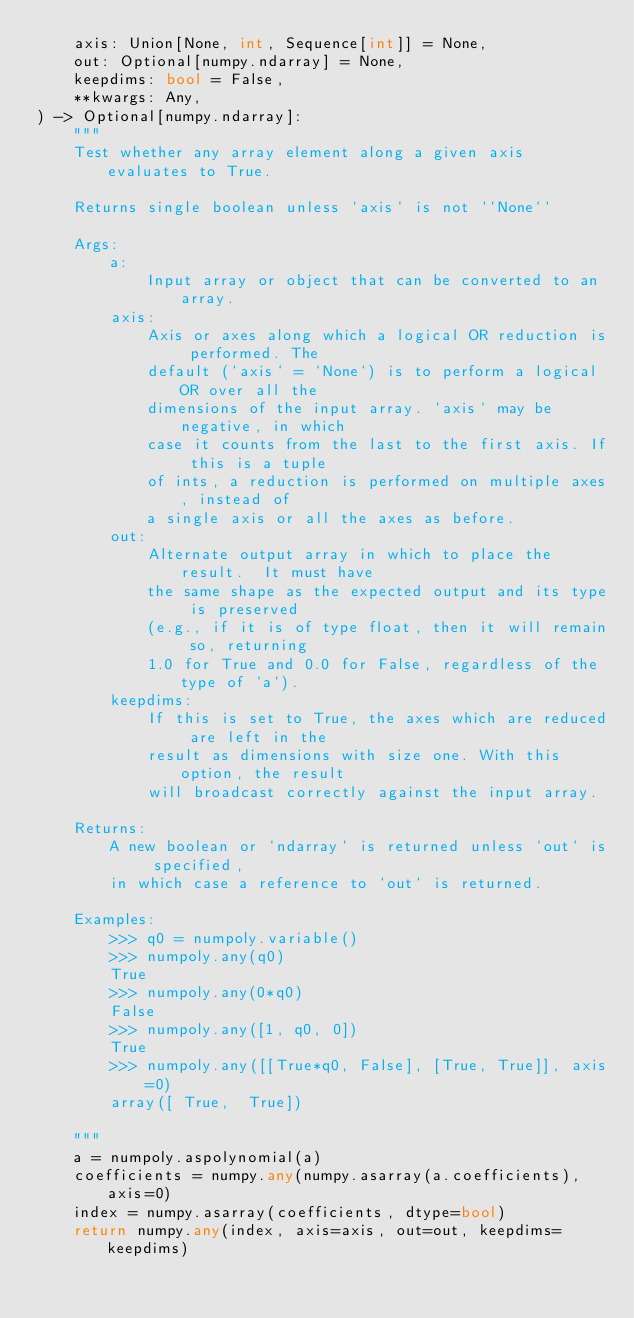<code> <loc_0><loc_0><loc_500><loc_500><_Python_>    axis: Union[None, int, Sequence[int]] = None,
    out: Optional[numpy.ndarray] = None,
    keepdims: bool = False,
    **kwargs: Any,
) -> Optional[numpy.ndarray]:
    """
    Test whether any array element along a given axis evaluates to True.

    Returns single boolean unless `axis` is not ``None``

    Args:
        a:
            Input array or object that can be converted to an array.
        axis:
            Axis or axes along which a logical OR reduction is performed. The
            default (`axis` = `None`) is to perform a logical OR over all the
            dimensions of the input array. `axis` may be negative, in which
            case it counts from the last to the first axis. If this is a tuple
            of ints, a reduction is performed on multiple axes, instead of
            a single axis or all the axes as before.
        out:
            Alternate output array in which to place the result.  It must have
            the same shape as the expected output and its type is preserved
            (e.g., if it is of type float, then it will remain so, returning
            1.0 for True and 0.0 for False, regardless of the type of `a`).
        keepdims:
            If this is set to True, the axes which are reduced are left in the
            result as dimensions with size one. With this option, the result
            will broadcast correctly against the input array.

    Returns:
        A new boolean or `ndarray` is returned unless `out` is specified,
        in which case a reference to `out` is returned.

    Examples:
        >>> q0 = numpoly.variable()
        >>> numpoly.any(q0)
        True
        >>> numpoly.any(0*q0)
        False
        >>> numpoly.any([1, q0, 0])
        True
        >>> numpoly.any([[True*q0, False], [True, True]], axis=0)
        array([ True,  True])

    """
    a = numpoly.aspolynomial(a)
    coefficients = numpy.any(numpy.asarray(a.coefficients), axis=0)
    index = numpy.asarray(coefficients, dtype=bool)
    return numpy.any(index, axis=axis, out=out, keepdims=keepdims)
</code> 